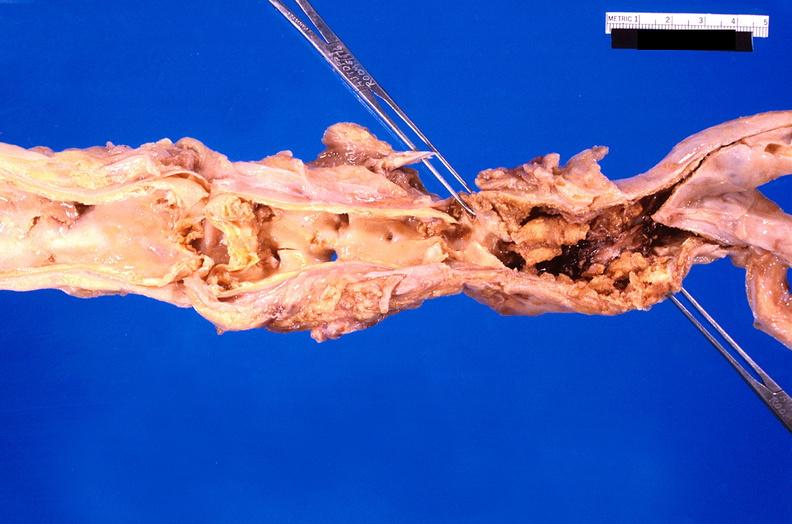s cardiovascular present?
Answer the question using a single word or phrase. Yes 